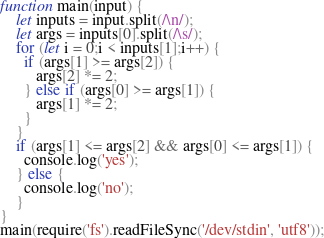Convert code to text. <code><loc_0><loc_0><loc_500><loc_500><_JavaScript_>function main(input) {
  	let inputs = input.split(/\n/);
 	let args = inputs[0].split(/\s/);
    for (let i = 0;i < inputs[1];i++) {
      if (args[1] >= args[2]) {
         args[2] *= 2;
      } else if (args[0] >= args[1]) {
         args[1] *= 2;
      }
    }
  	if (args[1] <= args[2] && args[0] <= args[1]) {
      console.log('yes');
    } else {
      console.log('no');
    }
}
main(require('fs').readFileSync('/dev/stdin', 'utf8'));</code> 